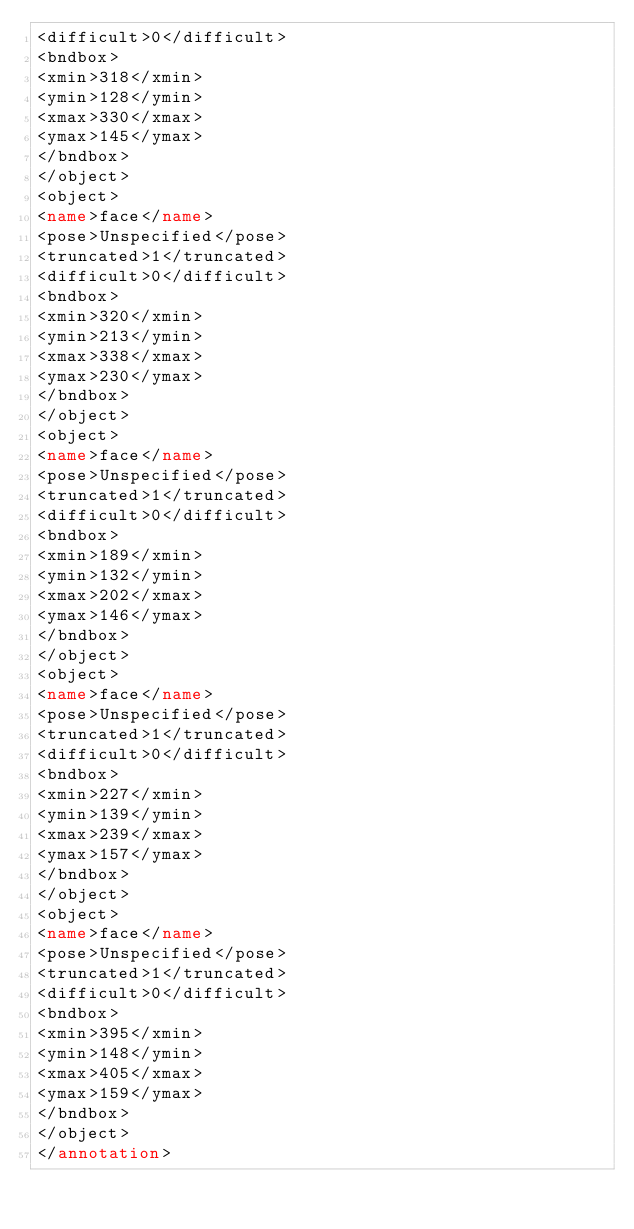<code> <loc_0><loc_0><loc_500><loc_500><_XML_><difficult>0</difficult>
<bndbox>
<xmin>318</xmin>
<ymin>128</ymin>
<xmax>330</xmax>
<ymax>145</ymax>
</bndbox>
</object>
<object>
<name>face</name>
<pose>Unspecified</pose>
<truncated>1</truncated>
<difficult>0</difficult>
<bndbox>
<xmin>320</xmin>
<ymin>213</ymin>
<xmax>338</xmax>
<ymax>230</ymax>
</bndbox>
</object>
<object>
<name>face</name>
<pose>Unspecified</pose>
<truncated>1</truncated>
<difficult>0</difficult>
<bndbox>
<xmin>189</xmin>
<ymin>132</ymin>
<xmax>202</xmax>
<ymax>146</ymax>
</bndbox>
</object>
<object>
<name>face</name>
<pose>Unspecified</pose>
<truncated>1</truncated>
<difficult>0</difficult>
<bndbox>
<xmin>227</xmin>
<ymin>139</ymin>
<xmax>239</xmax>
<ymax>157</ymax>
</bndbox>
</object>
<object>
<name>face</name>
<pose>Unspecified</pose>
<truncated>1</truncated>
<difficult>0</difficult>
<bndbox>
<xmin>395</xmin>
<ymin>148</ymin>
<xmax>405</xmax>
<ymax>159</ymax>
</bndbox>
</object>
</annotation>
</code> 